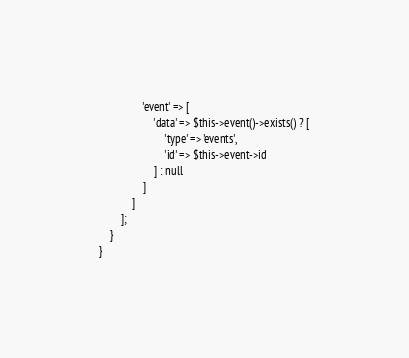Convert code to text. <code><loc_0><loc_0><loc_500><loc_500><_PHP_>                'event' => [
                    'data' => $this->event()->exists() ? [
                        'type' => 'events',
                        'id' => $this->event->id
                    ] : null
                ]
            ]
        ];
    }
}
</code> 